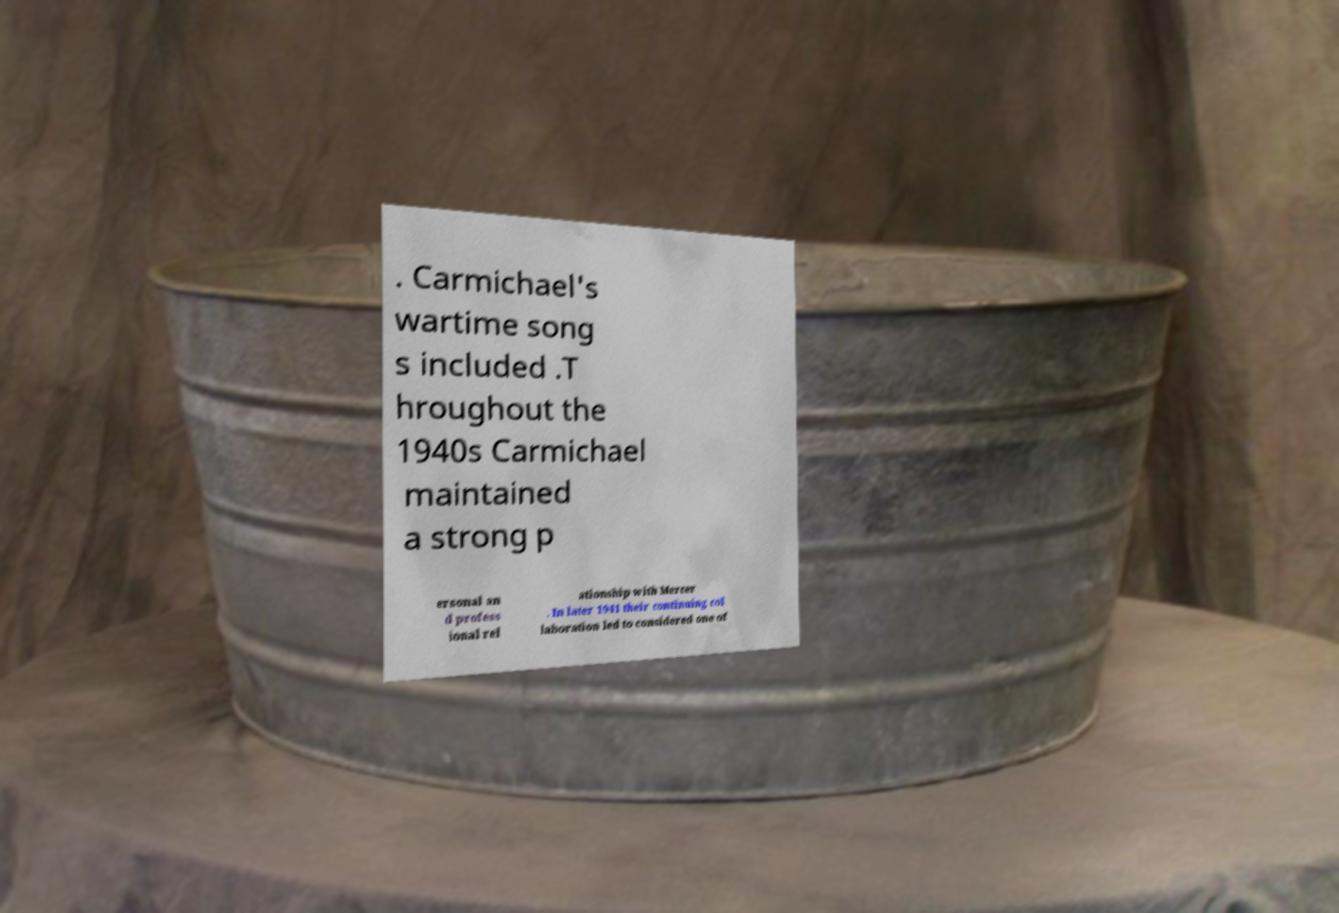What messages or text are displayed in this image? I need them in a readable, typed format. . Carmichael's wartime song s included .T hroughout the 1940s Carmichael maintained a strong p ersonal an d profess ional rel ationship with Mercer . In later 1941 their continuing col laboration led to considered one of 